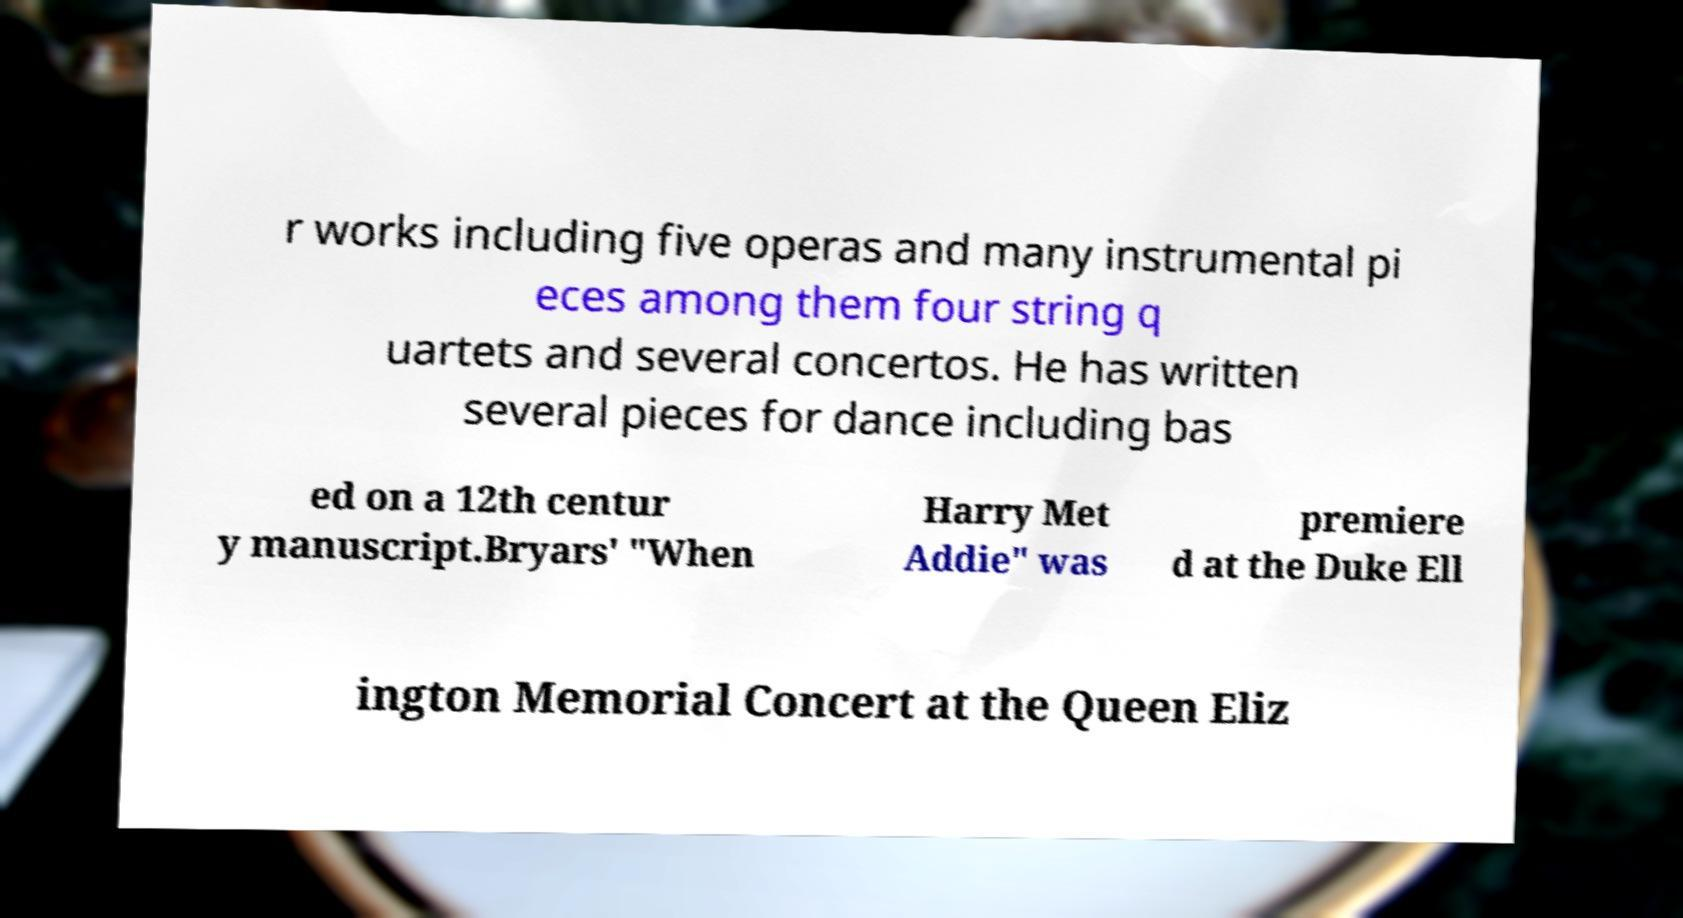For documentation purposes, I need the text within this image transcribed. Could you provide that? r works including five operas and many instrumental pi eces among them four string q uartets and several concertos. He has written several pieces for dance including bas ed on a 12th centur y manuscript.Bryars' "When Harry Met Addie" was premiere d at the Duke Ell ington Memorial Concert at the Queen Eliz 